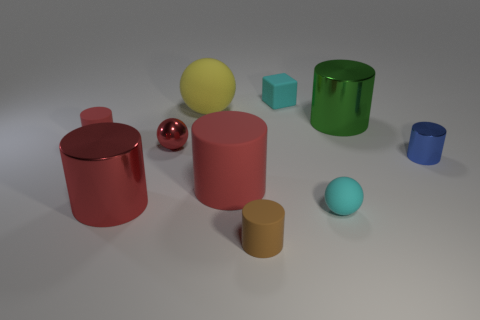Are there any cyan metallic cylinders? no 